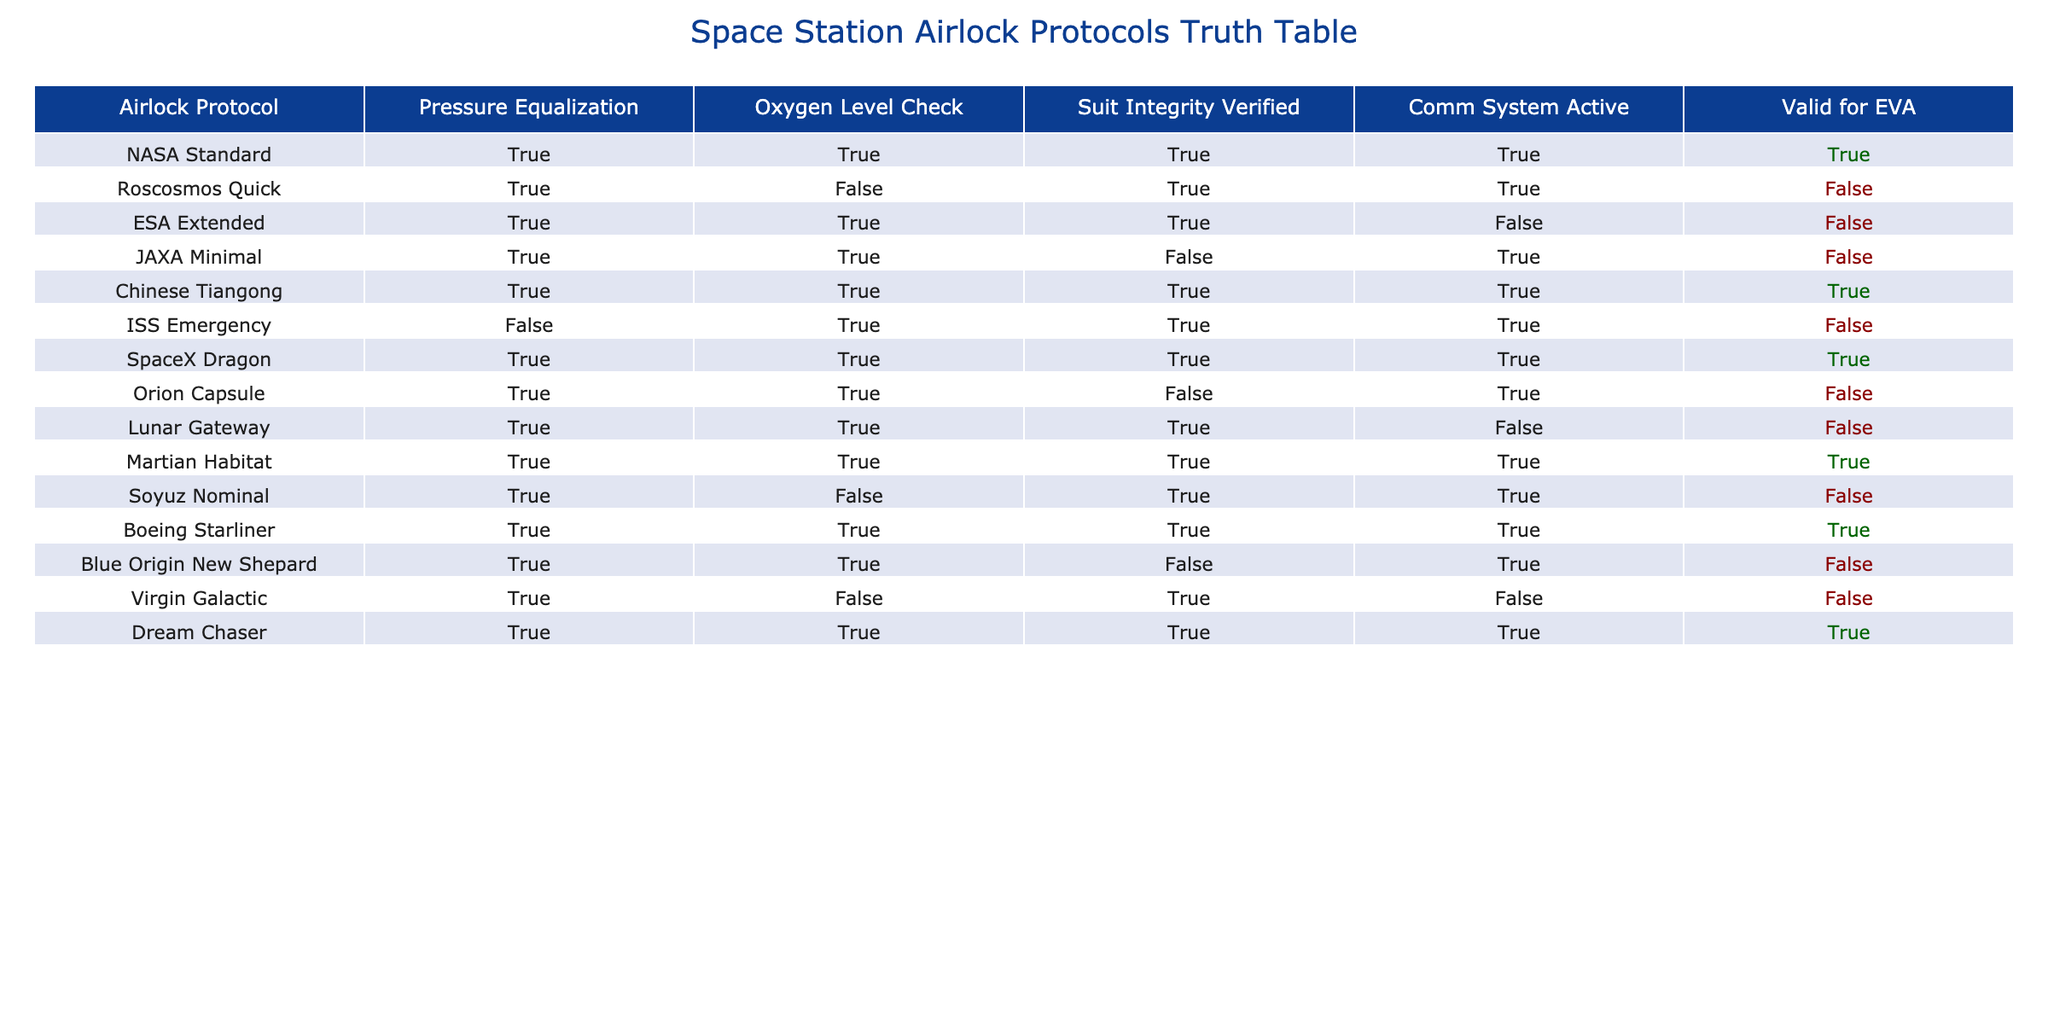What combination of airlock protocols requires a suit integrity check? To answer this, we look for all protocols in the table where "Suit Integrity Verified" is marked as TRUE. The protocols that meet this criterion are NASA Standard, Roscosmos Quick, Chinese Tiangong, SpaceX Dragon, Martian Habitat, and Boeing Starliner.
Answer: NASA Standard, Roscosmos Quick, Chinese Tiangong, SpaceX Dragon, Martian Habitat, Boeing Starliner Which airlock protocols are valid for EVA? Checking the "Valid for EVA" column, the airlock protocols marked as TRUE are NASA Standard, Chinese Tiangong, SpaceX Dragon, Martian Habitat, Boeing Starliner, and Dream Chaser.
Answer: NASA Standard, Chinese Tiangong, SpaceX Dragon, Martian Habitat, Boeing Starliner, Dream Chaser How many airlock protocols require an oxygen level check but are not valid for EVA? The valid airlock protocols requiring an "Oxygen Level Check" but marked FALSE in "Valid for EVA" are Roscosmos Quick, ESA Extended, JAXA Minimal, ISS Emergency, Soyuz Nominal, Virgin Galactic. There are a total of 6 such protocols.
Answer: 6 Which airlock protocols have both comm systems active and are valid for EVA? We look for protocols where both "Comm System Active" is TRUE and "Valid for EVA" is also TRUE. The protocols that meet these conditions are NASA Standard, Chinese Tiangong, SpaceX Dragon, and Dream Chaser.
Answer: NASA Standard, Chinese Tiangong, SpaceX Dragon, Dream Chaser Are there any airlock protocols that are valid for EVA but do not have an oxygen level check? From the table, we can see that ESA Extended, JAXA Minimal, ISS Emergency, Virgin Galactic, and Orion Capsule are marked as FALSE under "Oxygen Level Check" but are not valid for EVA. Thus, none are valid for EVA without an oxygen level check.
Answer: No 